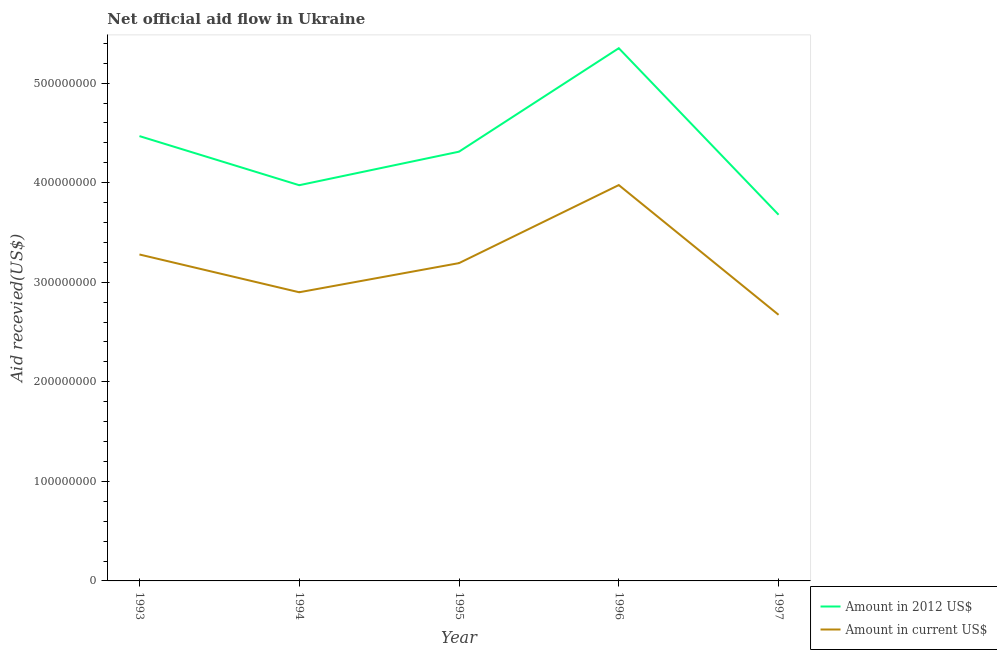Does the line corresponding to amount of aid received(expressed in 2012 us$) intersect with the line corresponding to amount of aid received(expressed in us$)?
Give a very brief answer. No. Is the number of lines equal to the number of legend labels?
Make the answer very short. Yes. What is the amount of aid received(expressed in 2012 us$) in 1997?
Your answer should be compact. 3.68e+08. Across all years, what is the maximum amount of aid received(expressed in 2012 us$)?
Provide a short and direct response. 5.35e+08. Across all years, what is the minimum amount of aid received(expressed in 2012 us$)?
Your answer should be compact. 3.68e+08. In which year was the amount of aid received(expressed in 2012 us$) maximum?
Ensure brevity in your answer.  1996. What is the total amount of aid received(expressed in 2012 us$) in the graph?
Give a very brief answer. 2.18e+09. What is the difference between the amount of aid received(expressed in us$) in 1994 and that in 1995?
Offer a very short reply. -2.93e+07. What is the difference between the amount of aid received(expressed in us$) in 1993 and the amount of aid received(expressed in 2012 us$) in 1997?
Provide a succinct answer. -3.99e+07. What is the average amount of aid received(expressed in 2012 us$) per year?
Your answer should be compact. 4.36e+08. In the year 1993, what is the difference between the amount of aid received(expressed in 2012 us$) and amount of aid received(expressed in us$)?
Offer a very short reply. 1.19e+08. In how many years, is the amount of aid received(expressed in 2012 us$) greater than 360000000 US$?
Your answer should be compact. 5. What is the ratio of the amount of aid received(expressed in us$) in 1995 to that in 1997?
Your response must be concise. 1.19. Is the difference between the amount of aid received(expressed in 2012 us$) in 1994 and 1996 greater than the difference between the amount of aid received(expressed in us$) in 1994 and 1996?
Offer a terse response. No. What is the difference between the highest and the second highest amount of aid received(expressed in us$)?
Keep it short and to the point. 6.97e+07. What is the difference between the highest and the lowest amount of aid received(expressed in 2012 us$)?
Your answer should be compact. 1.67e+08. Is the amount of aid received(expressed in us$) strictly greater than the amount of aid received(expressed in 2012 us$) over the years?
Your answer should be very brief. No. Is the amount of aid received(expressed in 2012 us$) strictly less than the amount of aid received(expressed in us$) over the years?
Your answer should be very brief. No. Are the values on the major ticks of Y-axis written in scientific E-notation?
Your response must be concise. No. Where does the legend appear in the graph?
Offer a terse response. Bottom right. How many legend labels are there?
Your answer should be very brief. 2. How are the legend labels stacked?
Your response must be concise. Vertical. What is the title of the graph?
Your response must be concise. Net official aid flow in Ukraine. What is the label or title of the X-axis?
Give a very brief answer. Year. What is the label or title of the Y-axis?
Give a very brief answer. Aid recevied(US$). What is the Aid recevied(US$) of Amount in 2012 US$ in 1993?
Make the answer very short. 4.47e+08. What is the Aid recevied(US$) of Amount in current US$ in 1993?
Provide a short and direct response. 3.28e+08. What is the Aid recevied(US$) of Amount in 2012 US$ in 1994?
Provide a succinct answer. 3.97e+08. What is the Aid recevied(US$) of Amount in current US$ in 1994?
Your response must be concise. 2.90e+08. What is the Aid recevied(US$) of Amount in 2012 US$ in 1995?
Keep it short and to the point. 4.31e+08. What is the Aid recevied(US$) of Amount in current US$ in 1995?
Ensure brevity in your answer.  3.19e+08. What is the Aid recevied(US$) in Amount in 2012 US$ in 1996?
Offer a very short reply. 5.35e+08. What is the Aid recevied(US$) of Amount in current US$ in 1996?
Provide a short and direct response. 3.98e+08. What is the Aid recevied(US$) in Amount in 2012 US$ in 1997?
Give a very brief answer. 3.68e+08. What is the Aid recevied(US$) in Amount in current US$ in 1997?
Give a very brief answer. 2.67e+08. Across all years, what is the maximum Aid recevied(US$) in Amount in 2012 US$?
Provide a succinct answer. 5.35e+08. Across all years, what is the maximum Aid recevied(US$) in Amount in current US$?
Ensure brevity in your answer.  3.98e+08. Across all years, what is the minimum Aid recevied(US$) in Amount in 2012 US$?
Make the answer very short. 3.68e+08. Across all years, what is the minimum Aid recevied(US$) of Amount in current US$?
Provide a short and direct response. 2.67e+08. What is the total Aid recevied(US$) in Amount in 2012 US$ in the graph?
Ensure brevity in your answer.  2.18e+09. What is the total Aid recevied(US$) of Amount in current US$ in the graph?
Provide a succinct answer. 1.60e+09. What is the difference between the Aid recevied(US$) of Amount in 2012 US$ in 1993 and that in 1994?
Provide a succinct answer. 4.93e+07. What is the difference between the Aid recevied(US$) of Amount in current US$ in 1993 and that in 1994?
Provide a succinct answer. 3.79e+07. What is the difference between the Aid recevied(US$) of Amount in 2012 US$ in 1993 and that in 1995?
Your response must be concise. 1.56e+07. What is the difference between the Aid recevied(US$) in Amount in current US$ in 1993 and that in 1995?
Ensure brevity in your answer.  8.67e+06. What is the difference between the Aid recevied(US$) of Amount in 2012 US$ in 1993 and that in 1996?
Give a very brief answer. -8.83e+07. What is the difference between the Aid recevied(US$) of Amount in current US$ in 1993 and that in 1996?
Your answer should be compact. -6.97e+07. What is the difference between the Aid recevied(US$) of Amount in 2012 US$ in 1993 and that in 1997?
Offer a terse response. 7.90e+07. What is the difference between the Aid recevied(US$) of Amount in current US$ in 1993 and that in 1997?
Provide a succinct answer. 6.06e+07. What is the difference between the Aid recevied(US$) in Amount in 2012 US$ in 1994 and that in 1995?
Ensure brevity in your answer.  -3.37e+07. What is the difference between the Aid recevied(US$) of Amount in current US$ in 1994 and that in 1995?
Your answer should be compact. -2.93e+07. What is the difference between the Aid recevied(US$) in Amount in 2012 US$ in 1994 and that in 1996?
Ensure brevity in your answer.  -1.38e+08. What is the difference between the Aid recevied(US$) in Amount in current US$ in 1994 and that in 1996?
Your response must be concise. -1.08e+08. What is the difference between the Aid recevied(US$) of Amount in 2012 US$ in 1994 and that in 1997?
Provide a succinct answer. 2.96e+07. What is the difference between the Aid recevied(US$) of Amount in current US$ in 1994 and that in 1997?
Your answer should be very brief. 2.26e+07. What is the difference between the Aid recevied(US$) in Amount in 2012 US$ in 1995 and that in 1996?
Provide a short and direct response. -1.04e+08. What is the difference between the Aid recevied(US$) of Amount in current US$ in 1995 and that in 1996?
Ensure brevity in your answer.  -7.84e+07. What is the difference between the Aid recevied(US$) of Amount in 2012 US$ in 1995 and that in 1997?
Keep it short and to the point. 6.33e+07. What is the difference between the Aid recevied(US$) in Amount in current US$ in 1995 and that in 1997?
Keep it short and to the point. 5.19e+07. What is the difference between the Aid recevied(US$) in Amount in 2012 US$ in 1996 and that in 1997?
Give a very brief answer. 1.67e+08. What is the difference between the Aid recevied(US$) in Amount in current US$ in 1996 and that in 1997?
Your response must be concise. 1.30e+08. What is the difference between the Aid recevied(US$) of Amount in 2012 US$ in 1993 and the Aid recevied(US$) of Amount in current US$ in 1994?
Make the answer very short. 1.57e+08. What is the difference between the Aid recevied(US$) of Amount in 2012 US$ in 1993 and the Aid recevied(US$) of Amount in current US$ in 1995?
Give a very brief answer. 1.28e+08. What is the difference between the Aid recevied(US$) in Amount in 2012 US$ in 1993 and the Aid recevied(US$) in Amount in current US$ in 1996?
Your answer should be compact. 4.92e+07. What is the difference between the Aid recevied(US$) of Amount in 2012 US$ in 1993 and the Aid recevied(US$) of Amount in current US$ in 1997?
Make the answer very short. 1.80e+08. What is the difference between the Aid recevied(US$) in Amount in 2012 US$ in 1994 and the Aid recevied(US$) in Amount in current US$ in 1995?
Provide a succinct answer. 7.83e+07. What is the difference between the Aid recevied(US$) in Amount in 2012 US$ in 1994 and the Aid recevied(US$) in Amount in current US$ in 1997?
Provide a short and direct response. 1.30e+08. What is the difference between the Aid recevied(US$) of Amount in 2012 US$ in 1995 and the Aid recevied(US$) of Amount in current US$ in 1996?
Provide a succinct answer. 3.35e+07. What is the difference between the Aid recevied(US$) of Amount in 2012 US$ in 1995 and the Aid recevied(US$) of Amount in current US$ in 1997?
Offer a very short reply. 1.64e+08. What is the difference between the Aid recevied(US$) in Amount in 2012 US$ in 1996 and the Aid recevied(US$) in Amount in current US$ in 1997?
Provide a short and direct response. 2.68e+08. What is the average Aid recevied(US$) of Amount in 2012 US$ per year?
Your answer should be compact. 4.36e+08. What is the average Aid recevied(US$) in Amount in current US$ per year?
Keep it short and to the point. 3.20e+08. In the year 1993, what is the difference between the Aid recevied(US$) in Amount in 2012 US$ and Aid recevied(US$) in Amount in current US$?
Offer a terse response. 1.19e+08. In the year 1994, what is the difference between the Aid recevied(US$) of Amount in 2012 US$ and Aid recevied(US$) of Amount in current US$?
Keep it short and to the point. 1.08e+08. In the year 1995, what is the difference between the Aid recevied(US$) of Amount in 2012 US$ and Aid recevied(US$) of Amount in current US$?
Keep it short and to the point. 1.12e+08. In the year 1996, what is the difference between the Aid recevied(US$) in Amount in 2012 US$ and Aid recevied(US$) in Amount in current US$?
Your response must be concise. 1.37e+08. In the year 1997, what is the difference between the Aid recevied(US$) in Amount in 2012 US$ and Aid recevied(US$) in Amount in current US$?
Provide a short and direct response. 1.01e+08. What is the ratio of the Aid recevied(US$) of Amount in 2012 US$ in 1993 to that in 1994?
Provide a short and direct response. 1.12. What is the ratio of the Aid recevied(US$) in Amount in current US$ in 1993 to that in 1994?
Give a very brief answer. 1.13. What is the ratio of the Aid recevied(US$) of Amount in 2012 US$ in 1993 to that in 1995?
Your answer should be very brief. 1.04. What is the ratio of the Aid recevied(US$) of Amount in current US$ in 1993 to that in 1995?
Give a very brief answer. 1.03. What is the ratio of the Aid recevied(US$) of Amount in 2012 US$ in 1993 to that in 1996?
Provide a short and direct response. 0.83. What is the ratio of the Aid recevied(US$) in Amount in current US$ in 1993 to that in 1996?
Ensure brevity in your answer.  0.82. What is the ratio of the Aid recevied(US$) in Amount in 2012 US$ in 1993 to that in 1997?
Your answer should be compact. 1.21. What is the ratio of the Aid recevied(US$) of Amount in current US$ in 1993 to that in 1997?
Your answer should be compact. 1.23. What is the ratio of the Aid recevied(US$) in Amount in 2012 US$ in 1994 to that in 1995?
Your answer should be very brief. 0.92. What is the ratio of the Aid recevied(US$) of Amount in current US$ in 1994 to that in 1995?
Your answer should be very brief. 0.91. What is the ratio of the Aid recevied(US$) of Amount in 2012 US$ in 1994 to that in 1996?
Offer a terse response. 0.74. What is the ratio of the Aid recevied(US$) of Amount in current US$ in 1994 to that in 1996?
Offer a very short reply. 0.73. What is the ratio of the Aid recevied(US$) of Amount in 2012 US$ in 1994 to that in 1997?
Keep it short and to the point. 1.08. What is the ratio of the Aid recevied(US$) in Amount in current US$ in 1994 to that in 1997?
Provide a short and direct response. 1.08. What is the ratio of the Aid recevied(US$) in Amount in 2012 US$ in 1995 to that in 1996?
Offer a very short reply. 0.81. What is the ratio of the Aid recevied(US$) in Amount in current US$ in 1995 to that in 1996?
Your answer should be very brief. 0.8. What is the ratio of the Aid recevied(US$) of Amount in 2012 US$ in 1995 to that in 1997?
Your response must be concise. 1.17. What is the ratio of the Aid recevied(US$) of Amount in current US$ in 1995 to that in 1997?
Provide a succinct answer. 1.19. What is the ratio of the Aid recevied(US$) of Amount in 2012 US$ in 1996 to that in 1997?
Offer a terse response. 1.45. What is the ratio of the Aid recevied(US$) in Amount in current US$ in 1996 to that in 1997?
Your response must be concise. 1.49. What is the difference between the highest and the second highest Aid recevied(US$) in Amount in 2012 US$?
Give a very brief answer. 8.83e+07. What is the difference between the highest and the second highest Aid recevied(US$) of Amount in current US$?
Provide a succinct answer. 6.97e+07. What is the difference between the highest and the lowest Aid recevied(US$) in Amount in 2012 US$?
Give a very brief answer. 1.67e+08. What is the difference between the highest and the lowest Aid recevied(US$) of Amount in current US$?
Make the answer very short. 1.30e+08. 